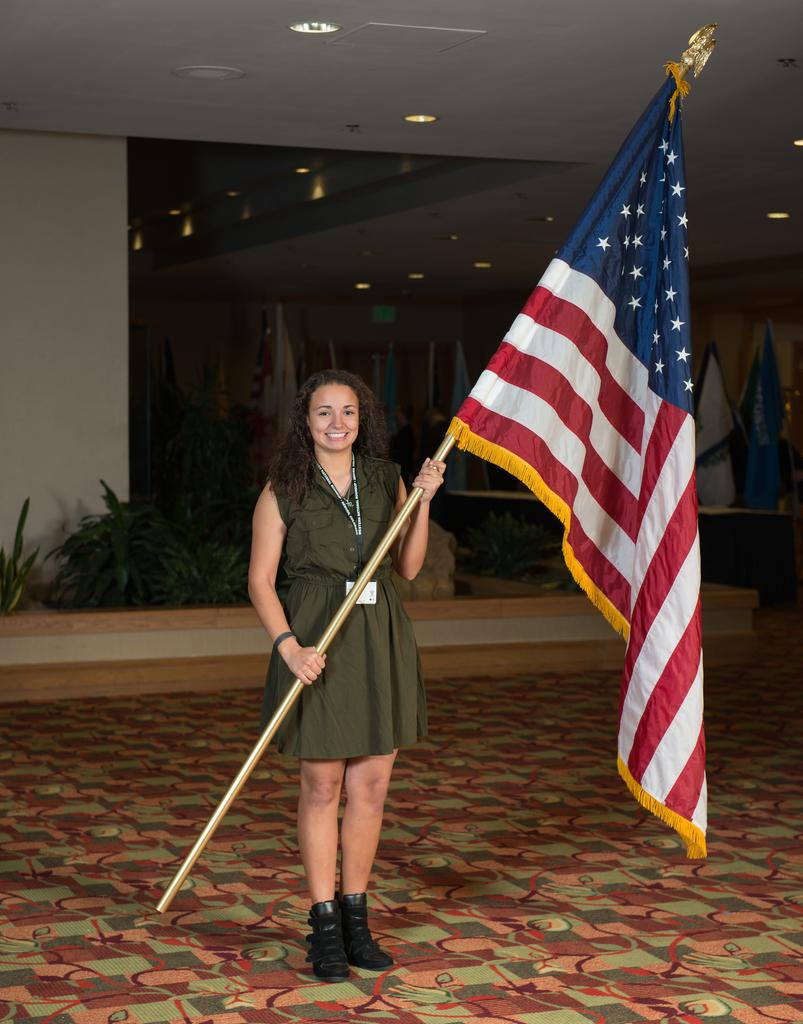Who is the main subject in the image? There is a woman in the image. What is the woman doing in the image? The woman is standing on the floor and holding a pole of a flag. What can be seen in the background of the image? There are flags, lights, and plants in the background of the image. What type of surprise does the manager have for the woman in the image? There is no manager present in the image, and therefore no surprise can be attributed to them. 